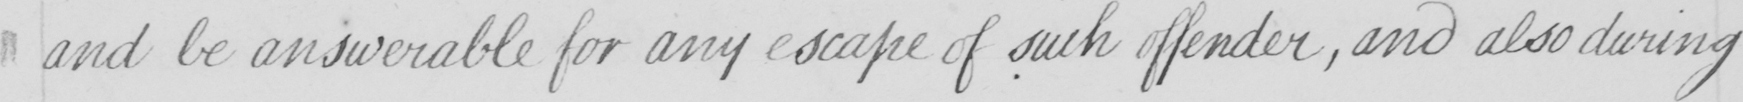Please transcribe the handwritten text in this image. and be answerable for any escape of such offender , and also during 